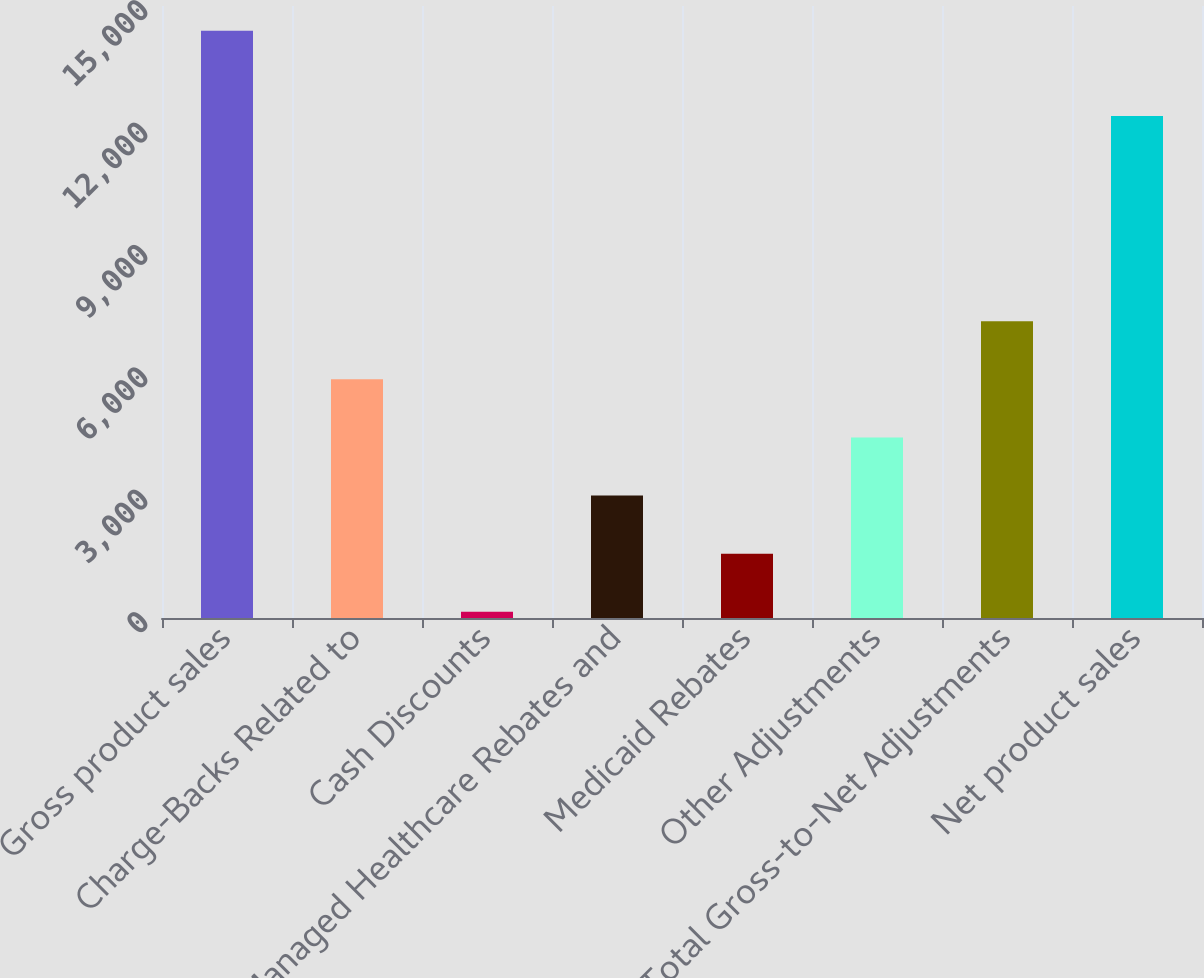<chart> <loc_0><loc_0><loc_500><loc_500><bar_chart><fcel>Gross product sales<fcel>Charge-Backs Related to<fcel>Cash Discounts<fcel>Managed Healthcare Rebates and<fcel>Medicaid Rebates<fcel>Other Adjustments<fcel>Total Gross-to-Net Adjustments<fcel>Net product sales<nl><fcel>14391<fcel>5848.8<fcel>154<fcel>3001.4<fcel>1577.7<fcel>4425.1<fcel>7272.5<fcel>12304<nl></chart> 